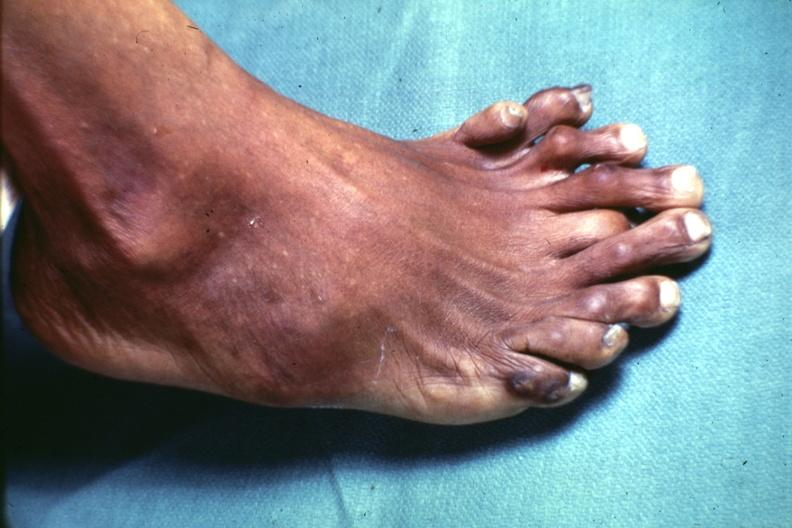what are present?
Answer the question using a single word or phrase. Extremities 